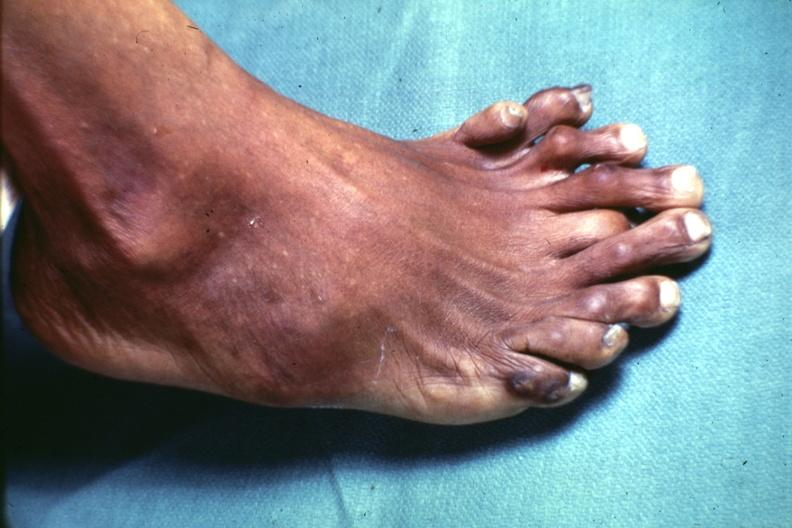what are present?
Answer the question using a single word or phrase. Extremities 